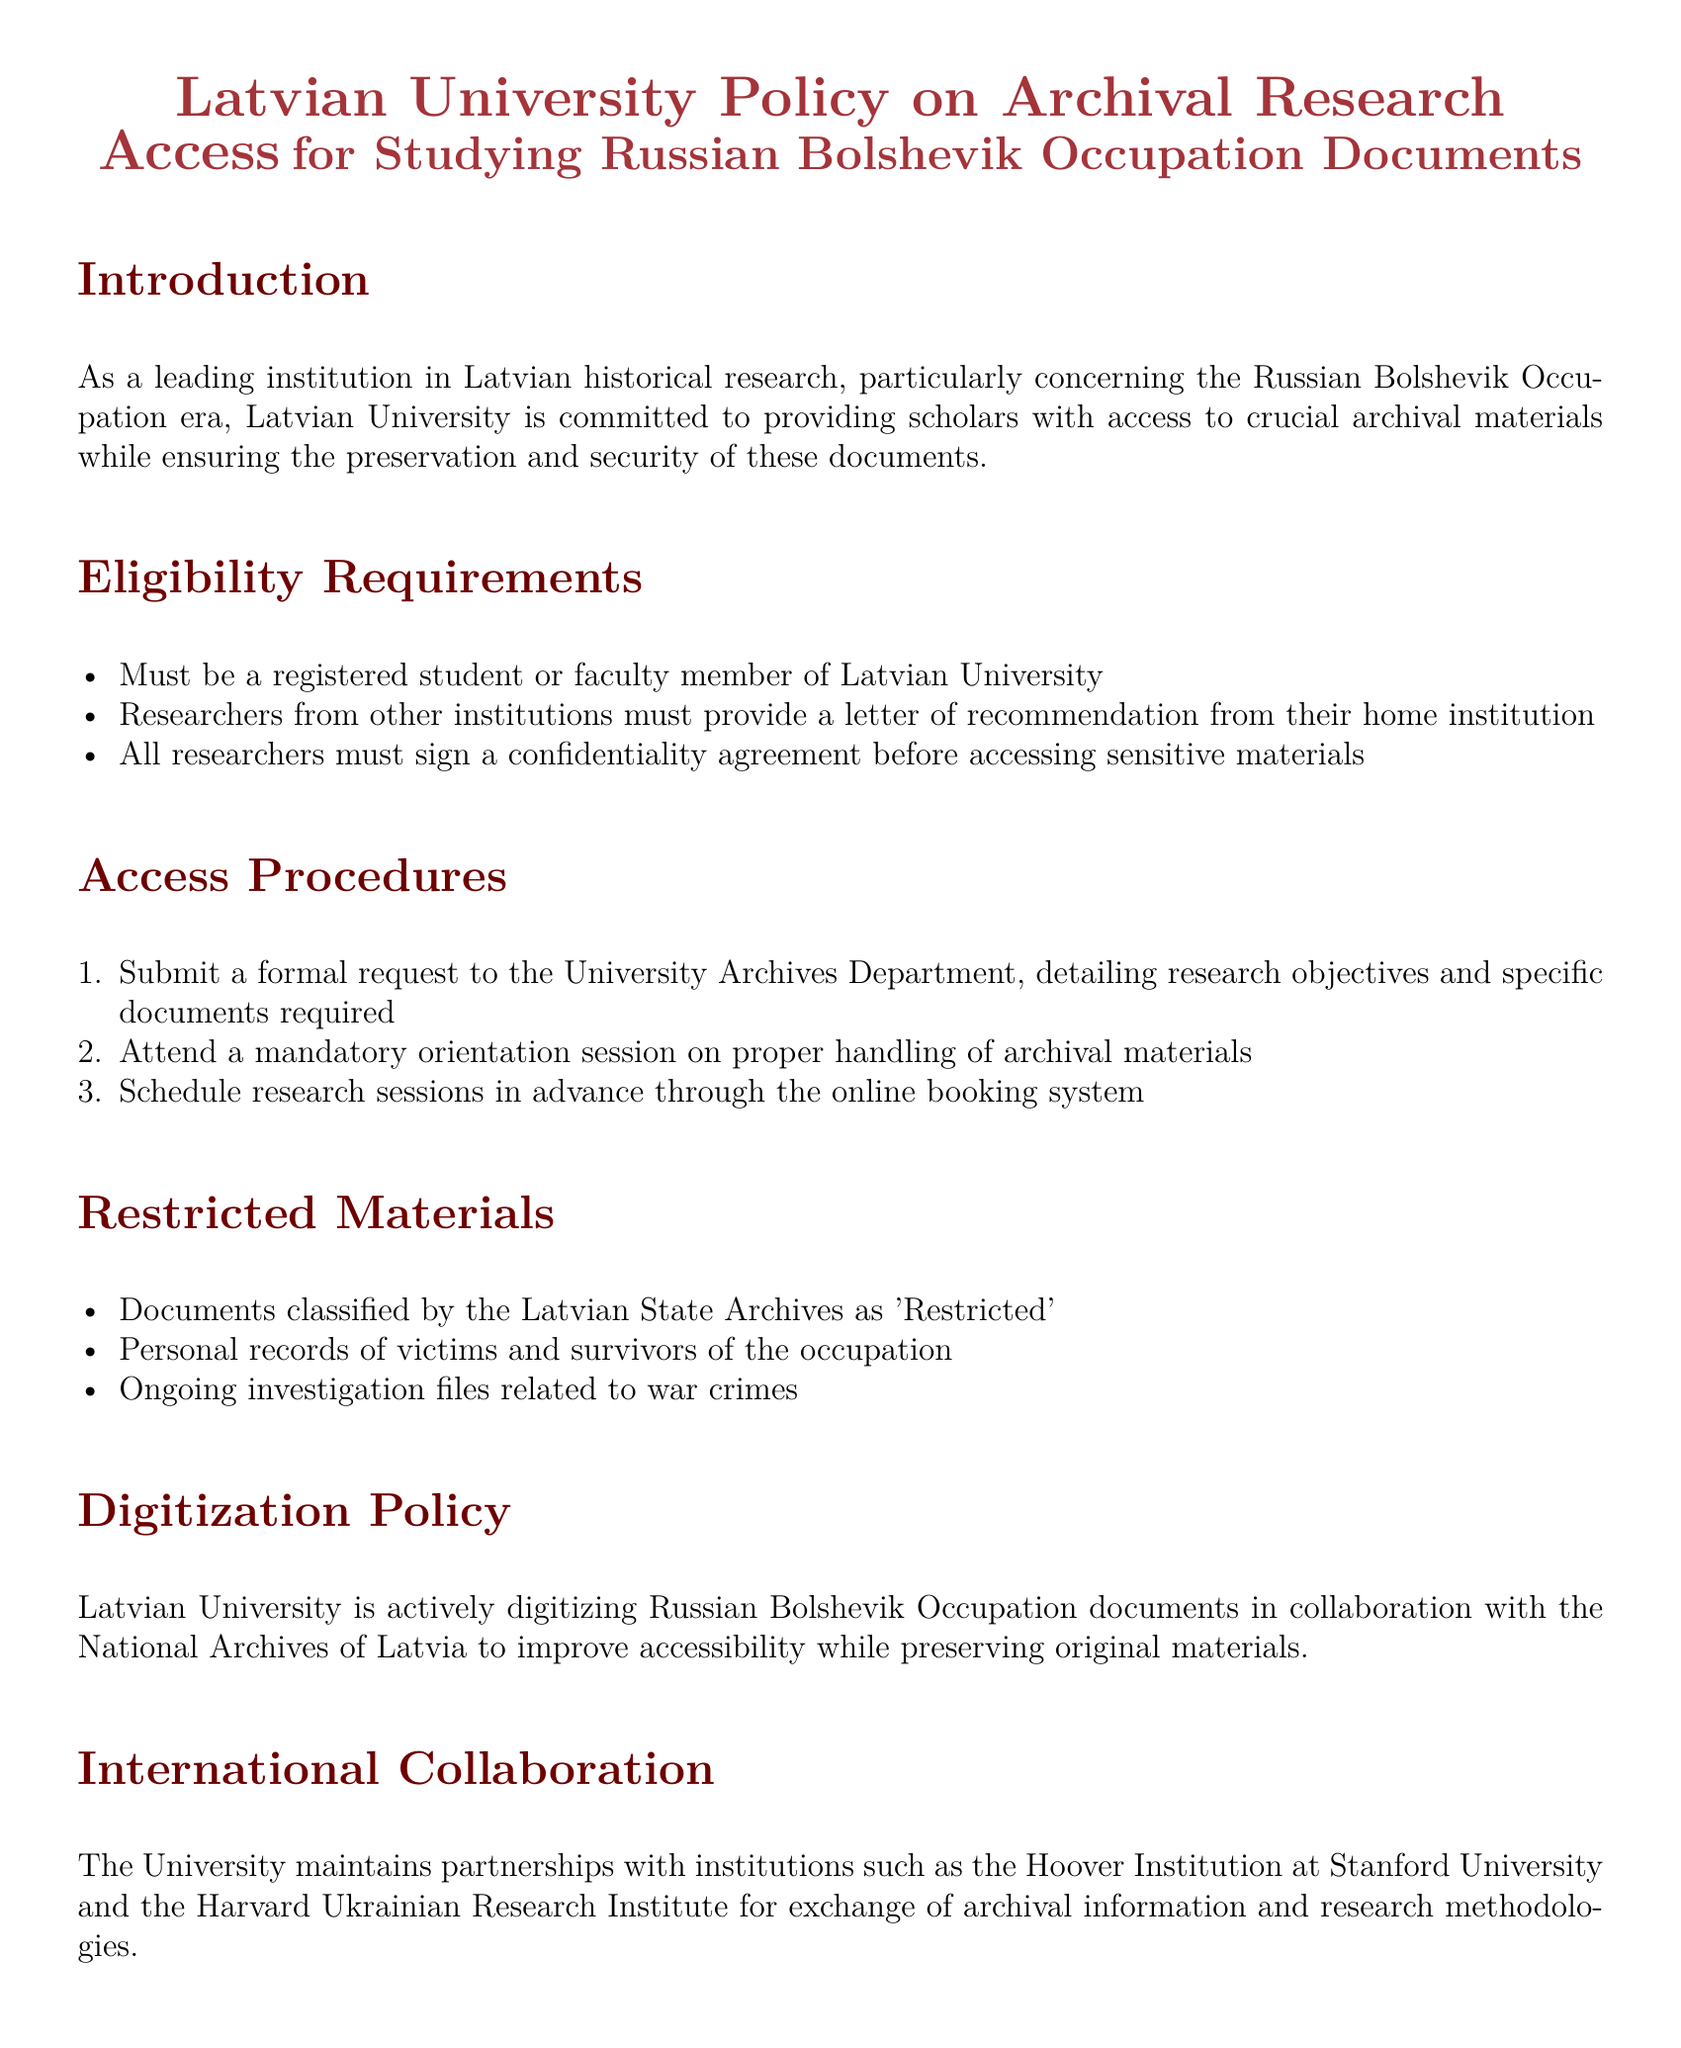What is the title of the document? The title reflects the focus of the policy document, which is about access to archival research related to a specific historical period.
Answer: Latvian University Policy on Archival Research Access for Studying Russian Bolshevik Occupation Documents Who must provide a letter of recommendation? This eligibility requirement specifies who is allowed to access the archives from outside the university.
Answer: Researchers from other institutions What must all researchers sign before accessing materials? This requirement outlines a key step for researchers to protect sensitive information while accessing archival documents.
Answer: Confidentiality agreement What type of documents are classified as 'Restricted'? The document specifies certain materials that cannot be accessed and identifies them by their classification status.
Answer: Documents classified by the Latvian State Archives as 'Restricted' What is the email address for the University Archives Department? This contact information allows researchers to inquire or submit requests related to archival access.
Answer: archives@lu.lv How many steps are there in the access procedures? The document outlines a sequence of actions required to access the archives, detailing a structured process.
Answer: Three Which institutions does Latvian University collaborate with for archival research? This question highlights the university's partnerships, which enhance the research capabilities and resources available to scholars.
Answer: Hoover Institution at Stanford University and the Harvard Ukrainian Research Institute What is the purpose of the digitization policy mentioned? The document indicates a proactive approach to making archival materials more accessible while preserving them.
Answer: Improve accessibility while preserving original materials What is required before scheduling research sessions? This rule sets a prerequisite for potential researchers to prepare adequately for handling archival documents.
Answer: Mandatory orientation session 